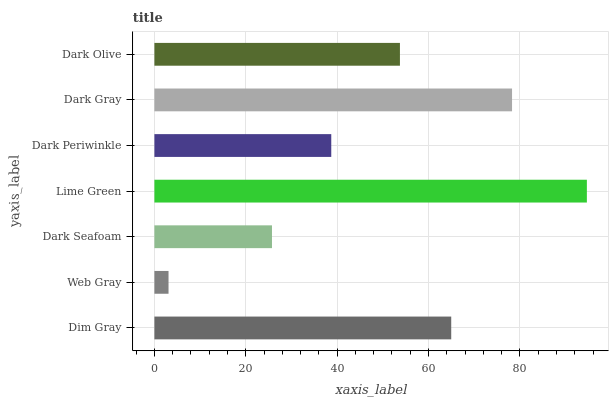Is Web Gray the minimum?
Answer yes or no. Yes. Is Lime Green the maximum?
Answer yes or no. Yes. Is Dark Seafoam the minimum?
Answer yes or no. No. Is Dark Seafoam the maximum?
Answer yes or no. No. Is Dark Seafoam greater than Web Gray?
Answer yes or no. Yes. Is Web Gray less than Dark Seafoam?
Answer yes or no. Yes. Is Web Gray greater than Dark Seafoam?
Answer yes or no. No. Is Dark Seafoam less than Web Gray?
Answer yes or no. No. Is Dark Olive the high median?
Answer yes or no. Yes. Is Dark Olive the low median?
Answer yes or no. Yes. Is Dim Gray the high median?
Answer yes or no. No. Is Dark Periwinkle the low median?
Answer yes or no. No. 